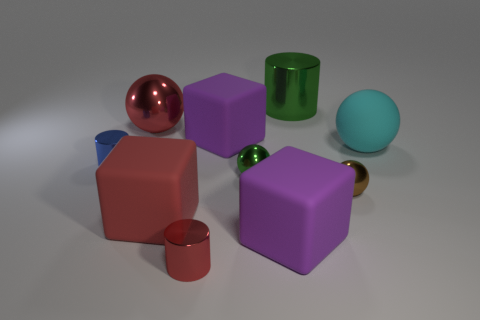The small object that is on the right side of the large red sphere and behind the tiny brown metallic ball is made of what material?
Offer a very short reply. Metal. Are any gray blocks visible?
Ensure brevity in your answer.  No. The large green thing that is made of the same material as the blue cylinder is what shape?
Make the answer very short. Cylinder. Do the brown object and the large shiny thing behind the large shiny ball have the same shape?
Provide a succinct answer. No. There is a cylinder on the left side of the metallic sphere behind the matte ball; what is its material?
Your response must be concise. Metal. How many other things are there of the same shape as the tiny green object?
Provide a succinct answer. 3. There is a big purple object that is behind the cyan object; is its shape the same as the large thing that is to the right of the big green metallic thing?
Ensure brevity in your answer.  No. Is there any other thing that has the same material as the brown thing?
Your answer should be compact. Yes. What material is the small blue thing?
Make the answer very short. Metal. There is a green object that is in front of the tiny blue object; what is it made of?
Offer a terse response. Metal. 